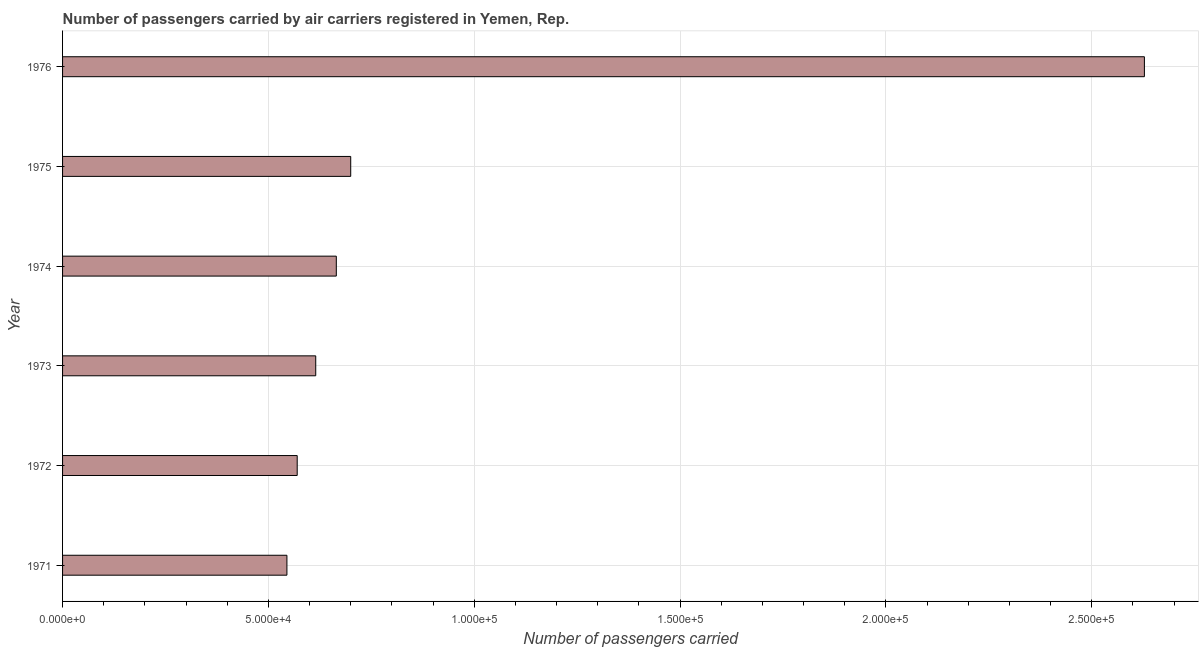Does the graph contain grids?
Your answer should be very brief. Yes. What is the title of the graph?
Your answer should be very brief. Number of passengers carried by air carriers registered in Yemen, Rep. What is the label or title of the X-axis?
Your answer should be compact. Number of passengers carried. What is the label or title of the Y-axis?
Your answer should be very brief. Year. What is the number of passengers carried in 1974?
Offer a very short reply. 6.65e+04. Across all years, what is the maximum number of passengers carried?
Keep it short and to the point. 2.63e+05. Across all years, what is the minimum number of passengers carried?
Give a very brief answer. 5.45e+04. In which year was the number of passengers carried maximum?
Your response must be concise. 1976. In which year was the number of passengers carried minimum?
Give a very brief answer. 1971. What is the sum of the number of passengers carried?
Keep it short and to the point. 5.72e+05. What is the difference between the number of passengers carried in 1973 and 1976?
Offer a terse response. -2.01e+05. What is the average number of passengers carried per year?
Provide a short and direct response. 9.54e+04. What is the median number of passengers carried?
Offer a terse response. 6.40e+04. In how many years, is the number of passengers carried greater than 90000 ?
Give a very brief answer. 1. Do a majority of the years between 1976 and 1973 (inclusive) have number of passengers carried greater than 160000 ?
Your response must be concise. Yes. What is the ratio of the number of passengers carried in 1973 to that in 1975?
Offer a terse response. 0.88. Is the number of passengers carried in 1972 less than that in 1973?
Provide a short and direct response. Yes. Is the difference between the number of passengers carried in 1971 and 1975 greater than the difference between any two years?
Make the answer very short. No. What is the difference between the highest and the second highest number of passengers carried?
Your answer should be very brief. 1.93e+05. What is the difference between the highest and the lowest number of passengers carried?
Give a very brief answer. 2.08e+05. Are all the bars in the graph horizontal?
Your answer should be very brief. Yes. What is the difference between two consecutive major ticks on the X-axis?
Your response must be concise. 5.00e+04. Are the values on the major ticks of X-axis written in scientific E-notation?
Make the answer very short. Yes. What is the Number of passengers carried in 1971?
Offer a very short reply. 5.45e+04. What is the Number of passengers carried in 1972?
Your answer should be compact. 5.70e+04. What is the Number of passengers carried in 1973?
Your answer should be very brief. 6.15e+04. What is the Number of passengers carried of 1974?
Offer a very short reply. 6.65e+04. What is the Number of passengers carried in 1976?
Ensure brevity in your answer.  2.63e+05. What is the difference between the Number of passengers carried in 1971 and 1972?
Keep it short and to the point. -2500. What is the difference between the Number of passengers carried in 1971 and 1973?
Provide a succinct answer. -7000. What is the difference between the Number of passengers carried in 1971 and 1974?
Ensure brevity in your answer.  -1.20e+04. What is the difference between the Number of passengers carried in 1971 and 1975?
Provide a short and direct response. -1.55e+04. What is the difference between the Number of passengers carried in 1971 and 1976?
Offer a very short reply. -2.08e+05. What is the difference between the Number of passengers carried in 1972 and 1973?
Offer a terse response. -4500. What is the difference between the Number of passengers carried in 1972 and 1974?
Your response must be concise. -9500. What is the difference between the Number of passengers carried in 1972 and 1975?
Offer a very short reply. -1.30e+04. What is the difference between the Number of passengers carried in 1972 and 1976?
Provide a short and direct response. -2.06e+05. What is the difference between the Number of passengers carried in 1973 and 1974?
Your answer should be very brief. -5000. What is the difference between the Number of passengers carried in 1973 and 1975?
Provide a short and direct response. -8500. What is the difference between the Number of passengers carried in 1973 and 1976?
Make the answer very short. -2.01e+05. What is the difference between the Number of passengers carried in 1974 and 1975?
Provide a short and direct response. -3500. What is the difference between the Number of passengers carried in 1974 and 1976?
Provide a short and direct response. -1.96e+05. What is the difference between the Number of passengers carried in 1975 and 1976?
Your response must be concise. -1.93e+05. What is the ratio of the Number of passengers carried in 1971 to that in 1972?
Provide a succinct answer. 0.96. What is the ratio of the Number of passengers carried in 1971 to that in 1973?
Provide a succinct answer. 0.89. What is the ratio of the Number of passengers carried in 1971 to that in 1974?
Your answer should be compact. 0.82. What is the ratio of the Number of passengers carried in 1971 to that in 1975?
Provide a short and direct response. 0.78. What is the ratio of the Number of passengers carried in 1971 to that in 1976?
Provide a succinct answer. 0.21. What is the ratio of the Number of passengers carried in 1972 to that in 1973?
Ensure brevity in your answer.  0.93. What is the ratio of the Number of passengers carried in 1972 to that in 1974?
Offer a terse response. 0.86. What is the ratio of the Number of passengers carried in 1972 to that in 1975?
Ensure brevity in your answer.  0.81. What is the ratio of the Number of passengers carried in 1972 to that in 1976?
Your answer should be very brief. 0.22. What is the ratio of the Number of passengers carried in 1973 to that in 1974?
Your answer should be compact. 0.93. What is the ratio of the Number of passengers carried in 1973 to that in 1975?
Offer a very short reply. 0.88. What is the ratio of the Number of passengers carried in 1973 to that in 1976?
Ensure brevity in your answer.  0.23. What is the ratio of the Number of passengers carried in 1974 to that in 1975?
Make the answer very short. 0.95. What is the ratio of the Number of passengers carried in 1974 to that in 1976?
Your answer should be compact. 0.25. What is the ratio of the Number of passengers carried in 1975 to that in 1976?
Your response must be concise. 0.27. 